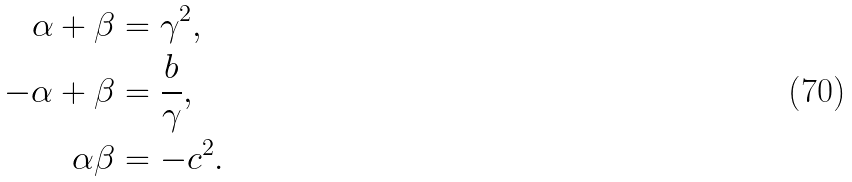Convert formula to latex. <formula><loc_0><loc_0><loc_500><loc_500>\alpha + \beta & = \gamma ^ { 2 } , \\ - \alpha + \beta & = \frac { b } { \gamma } , \\ \alpha \beta & = - c ^ { 2 } .</formula> 